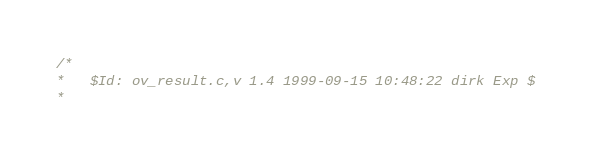<code> <loc_0><loc_0><loc_500><loc_500><_C_>/*
*   $Id: ov_result.c,v 1.4 1999-09-15 10:48:22 dirk Exp $
*</code> 